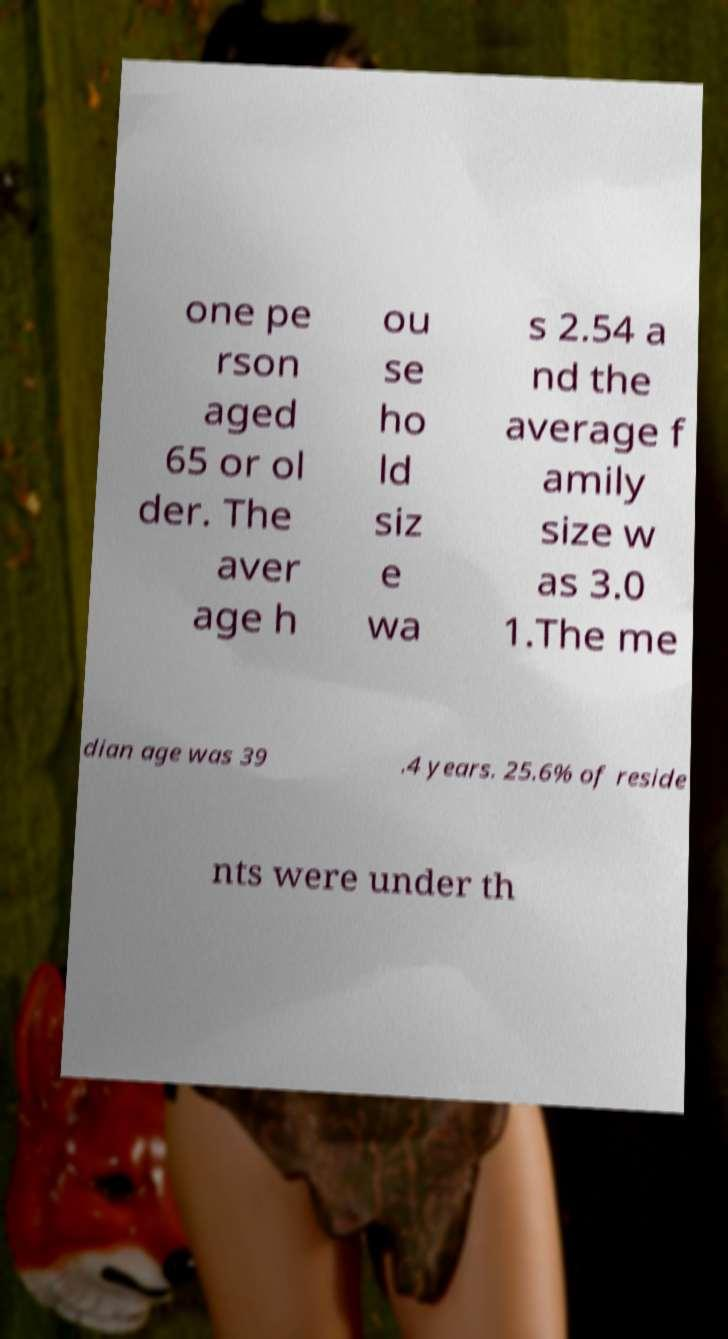Could you extract and type out the text from this image? one pe rson aged 65 or ol der. The aver age h ou se ho ld siz e wa s 2.54 a nd the average f amily size w as 3.0 1.The me dian age was 39 .4 years. 25.6% of reside nts were under th 